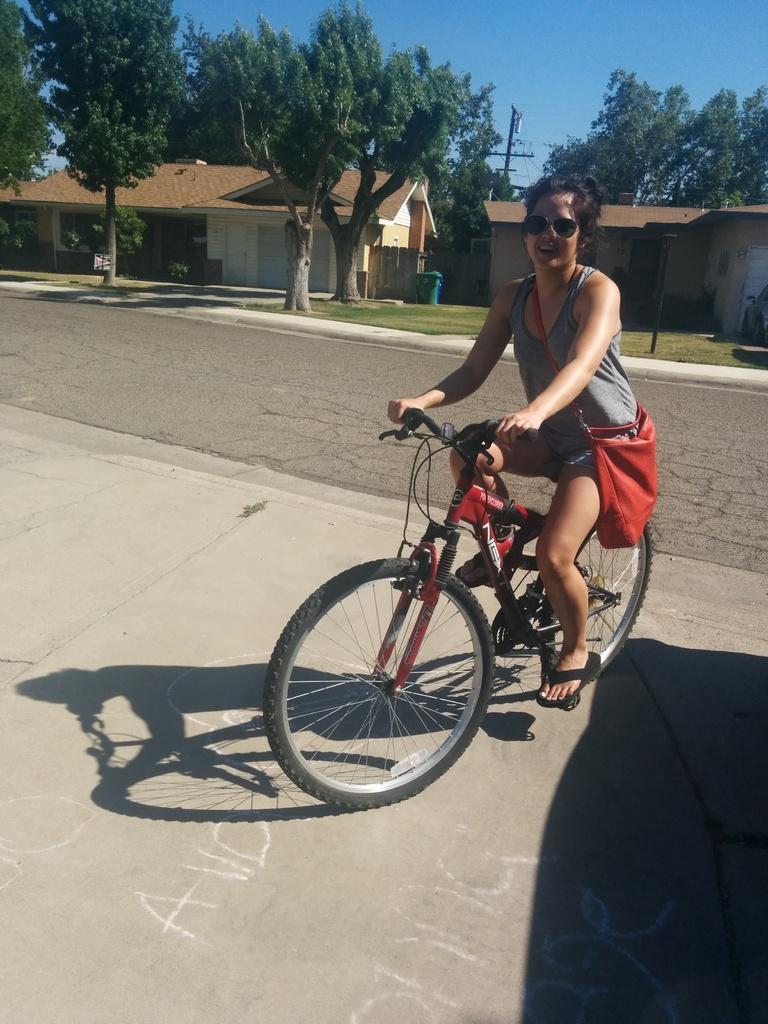In one or two sentences, can you explain what this image depicts? In this image there is a woman riding a bicycle in the center wearing a red colour bag and smiling. In the background there are trees, buildings, and there is grass on the ground, and there is a pole. 